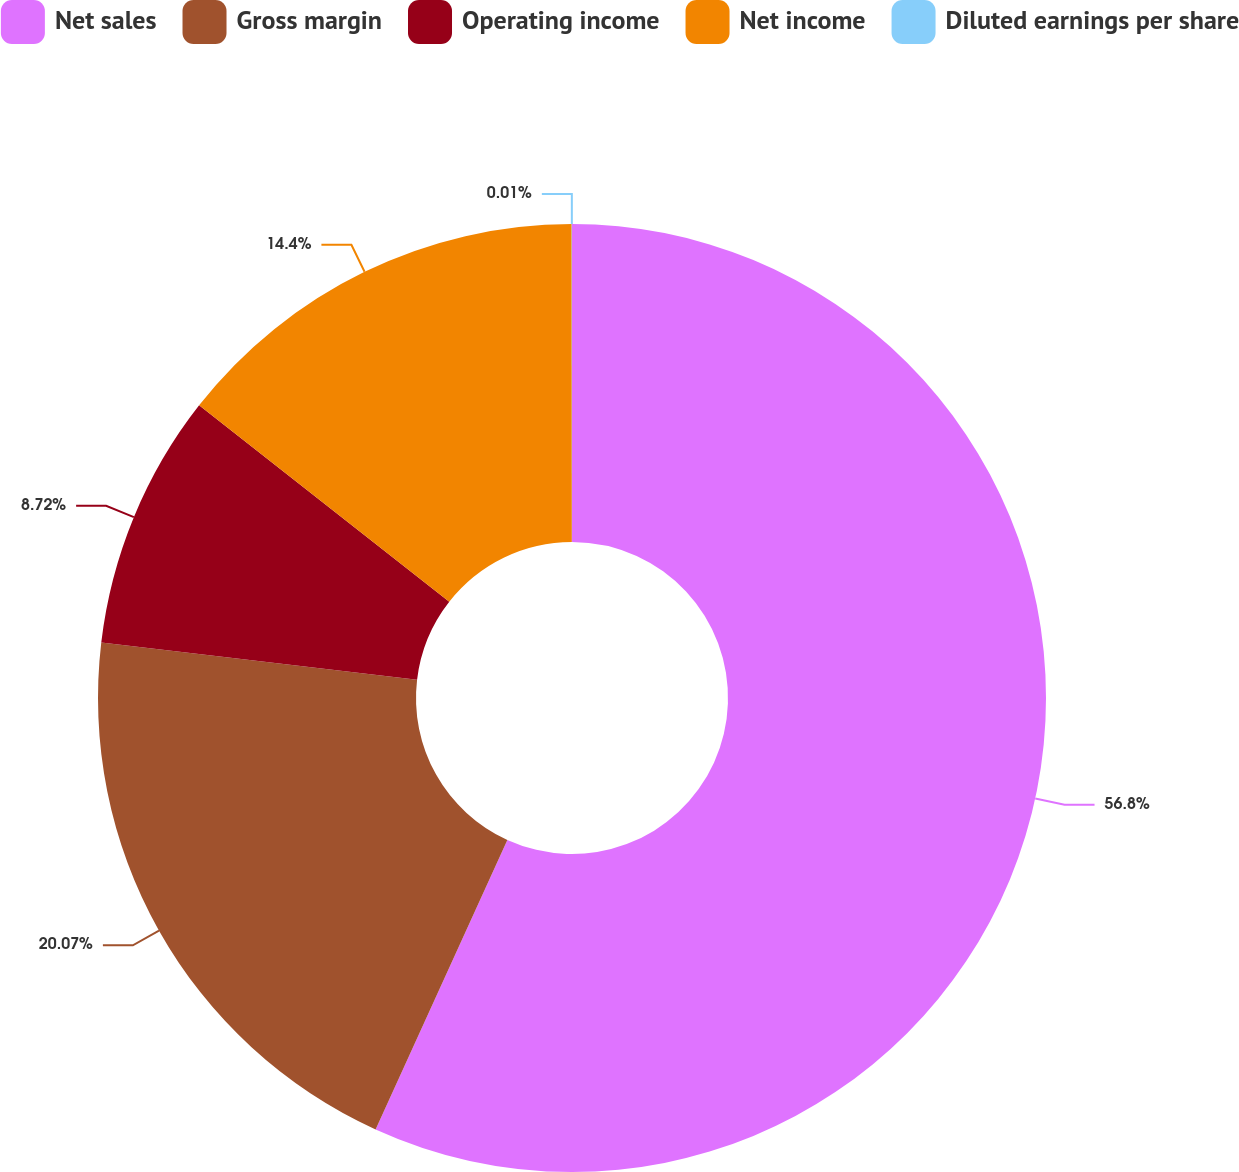Convert chart to OTSL. <chart><loc_0><loc_0><loc_500><loc_500><pie_chart><fcel>Net sales<fcel>Gross margin<fcel>Operating income<fcel>Net income<fcel>Diluted earnings per share<nl><fcel>56.8%<fcel>20.07%<fcel>8.72%<fcel>14.4%<fcel>0.01%<nl></chart> 